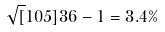<formula> <loc_0><loc_0><loc_500><loc_500>\sqrt { [ } 1 0 5 ] { 3 6 } - 1 = 3 . 4 \%</formula> 